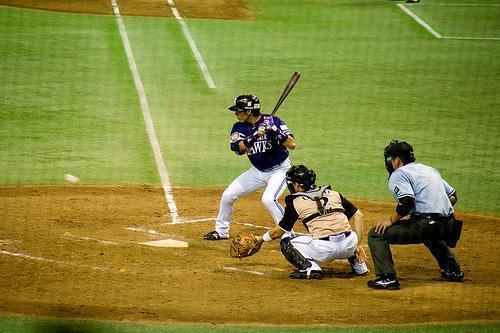How many people are in the photo?
Give a very brief answer. 3. 